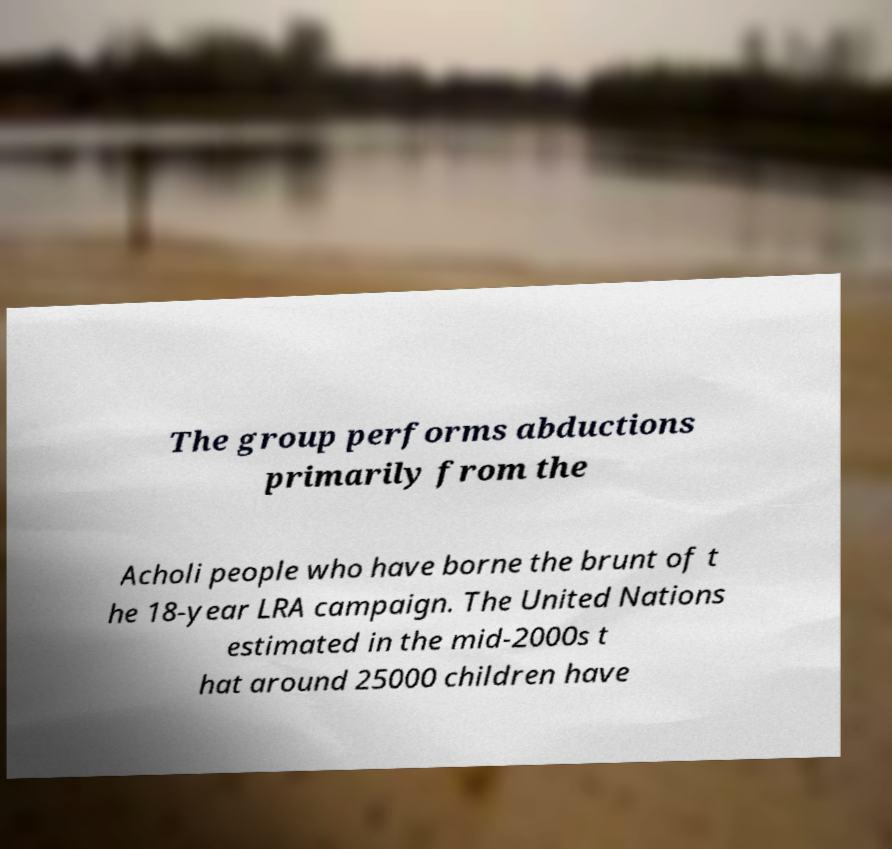Could you extract and type out the text from this image? The group performs abductions primarily from the Acholi people who have borne the brunt of t he 18-year LRA campaign. The United Nations estimated in the mid-2000s t hat around 25000 children have 